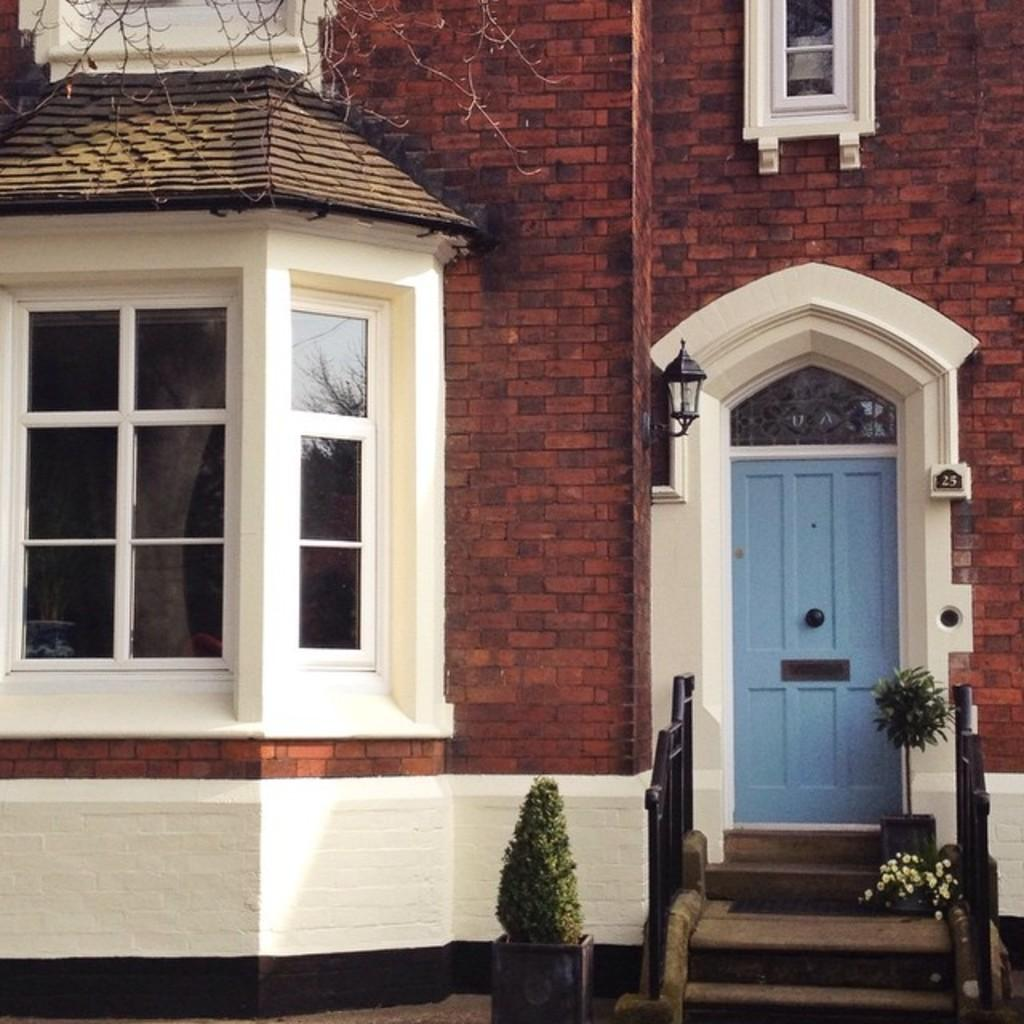What type of structure is visible in the image? There is a building in the image. What can be seen on the left side of the building? There are windows on the left side of the building. What is the color of the door on the right side of the building? There is a blue door on the right side of the building. How many grapes are hanging from the windows on the left side of the building? There are no grapes present in the image; the windows are on the left side of the building. 